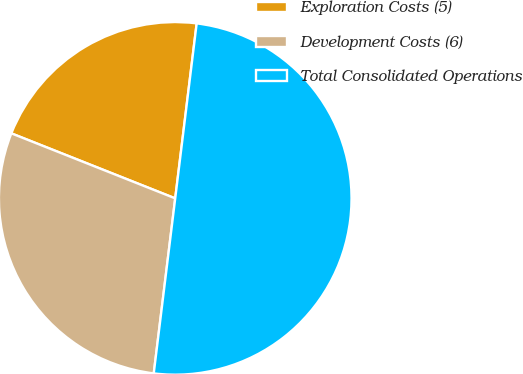Convert chart. <chart><loc_0><loc_0><loc_500><loc_500><pie_chart><fcel>Exploration Costs (5)<fcel>Development Costs (6)<fcel>Total Consolidated Operations<nl><fcel>20.93%<fcel>29.07%<fcel>50.0%<nl></chart> 